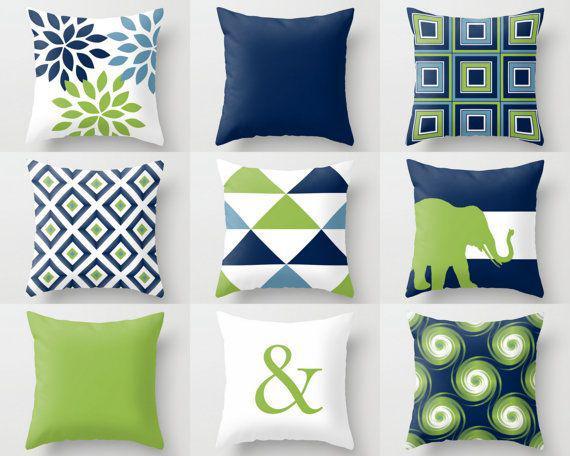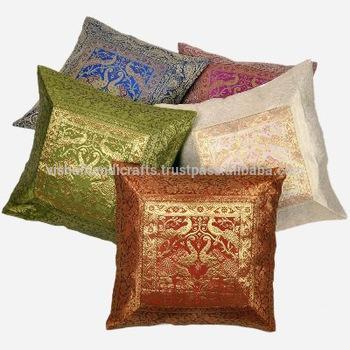The first image is the image on the left, the second image is the image on the right. Evaluate the accuracy of this statement regarding the images: "Throw pillows are laid on a couch in each image.". Is it true? Answer yes or no. No. The first image is the image on the left, the second image is the image on the right. Analyze the images presented: Is the assertion "Each image shows at least three colorful throw pillows on a solid-colored sofa." valid? Answer yes or no. No. 